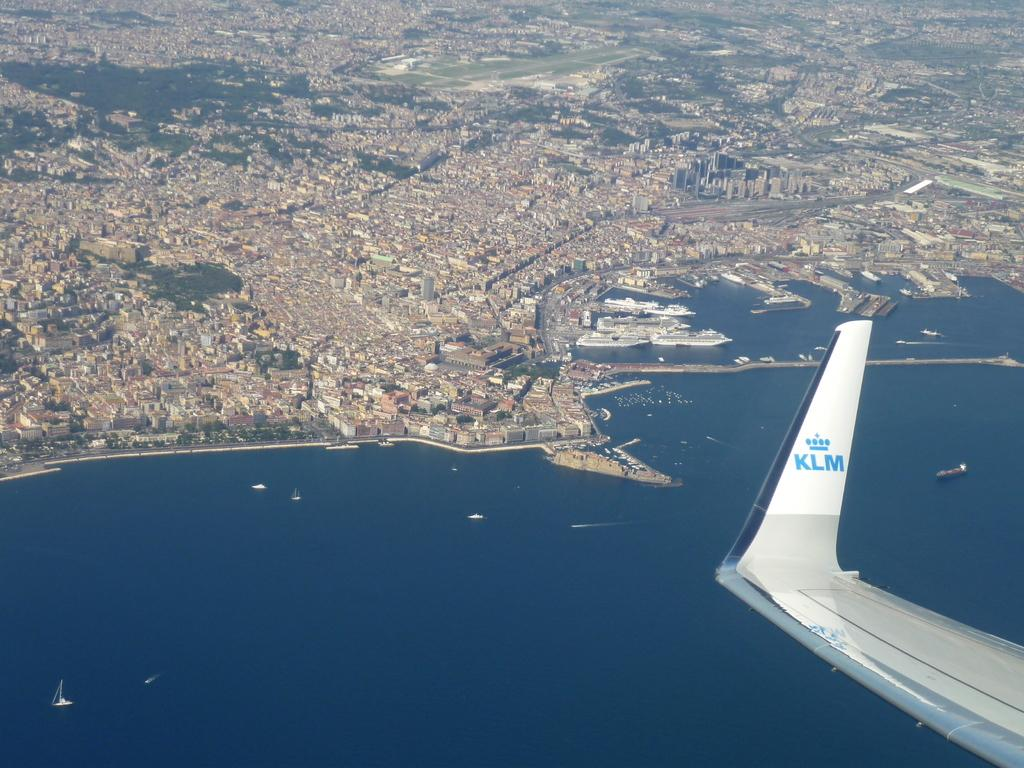<image>
Present a compact description of the photo's key features. The wing of an airplane with the KLM logo can be seen above water and land. 